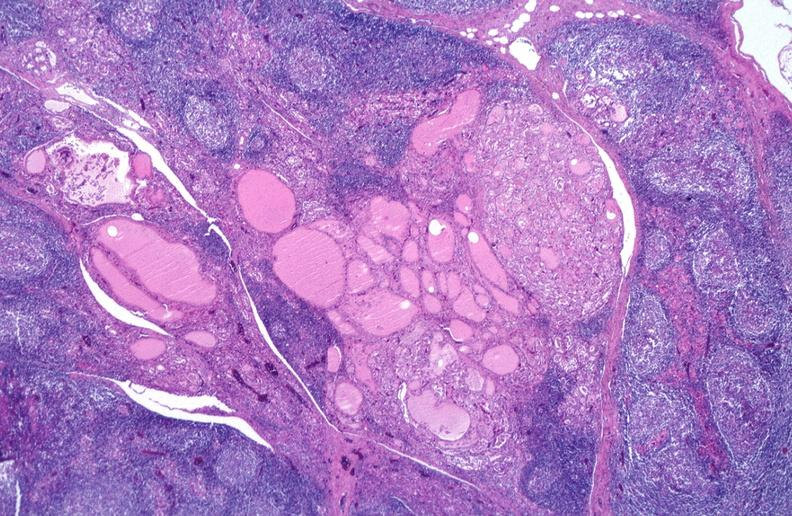where is this part in the figure?
Answer the question using a single word or phrase. Endocrine system 